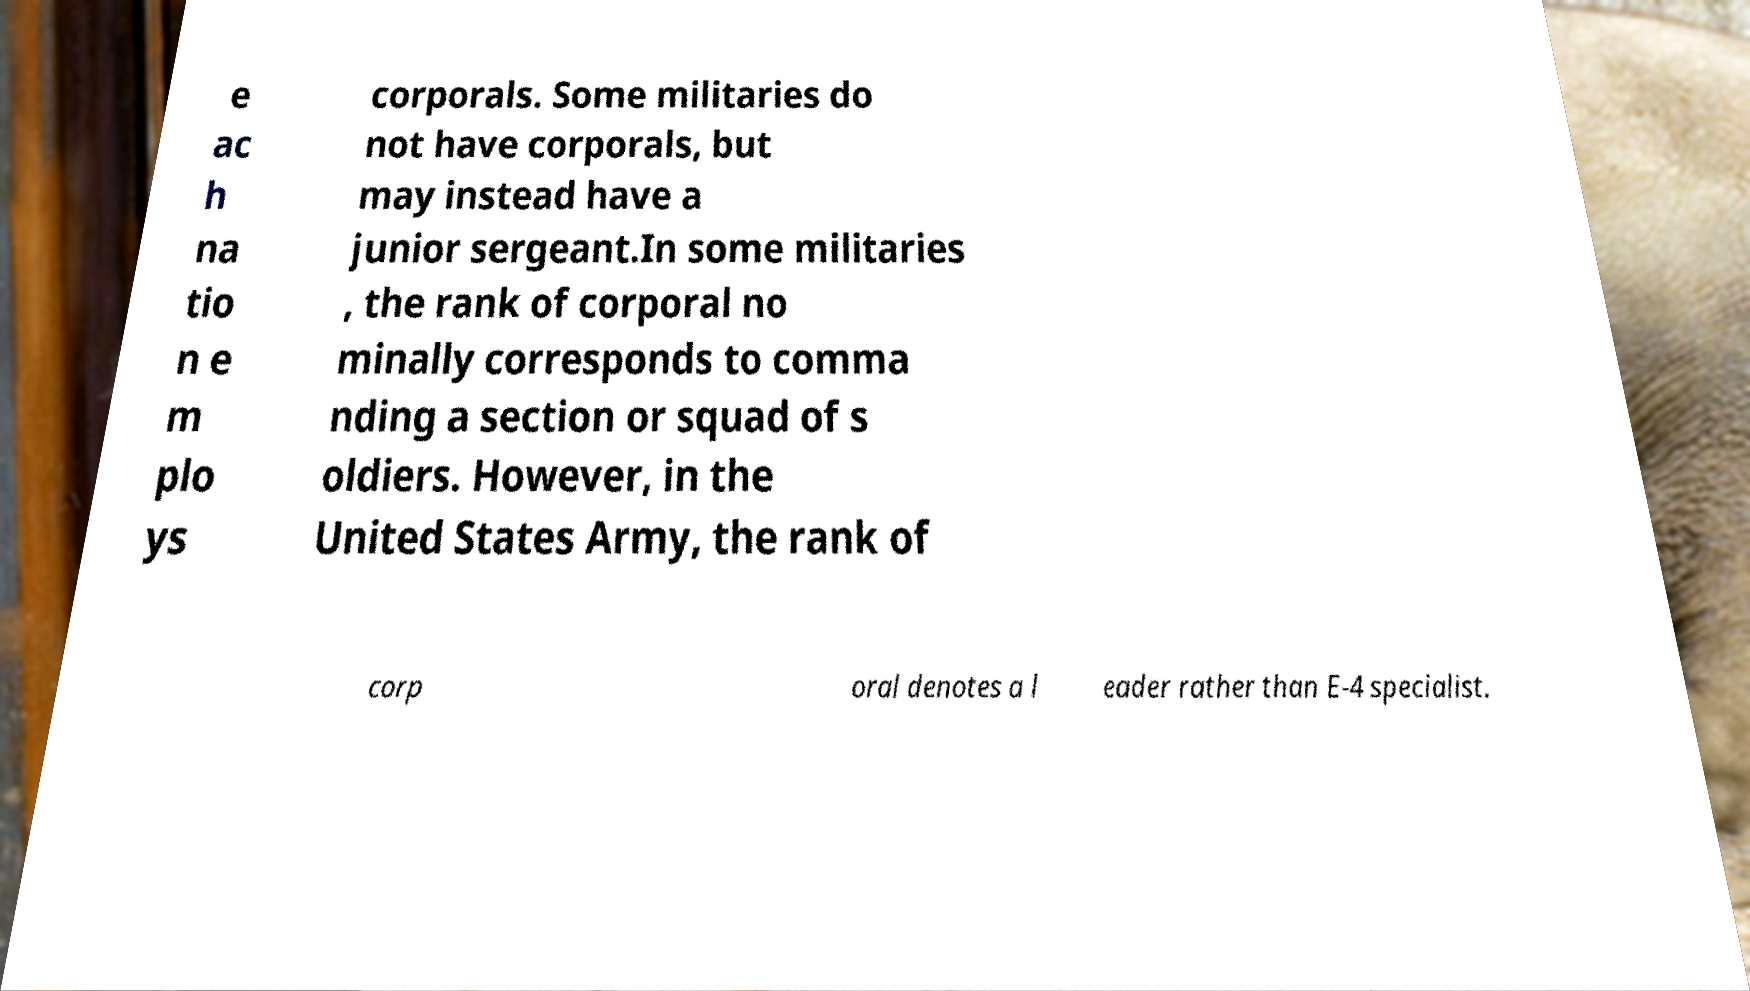Could you extract and type out the text from this image? e ac h na tio n e m plo ys corporals. Some militaries do not have corporals, but may instead have a junior sergeant.In some militaries , the rank of corporal no minally corresponds to comma nding a section or squad of s oldiers. However, in the United States Army, the rank of corp oral denotes a l eader rather than E-4 specialist. 